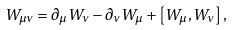<formula> <loc_0><loc_0><loc_500><loc_500>W _ { \mu \nu } = \partial _ { \mu } W _ { \nu } - \partial _ { \nu } W _ { \mu } + \left [ W _ { \mu } , W _ { \nu } \right ] ,</formula> 